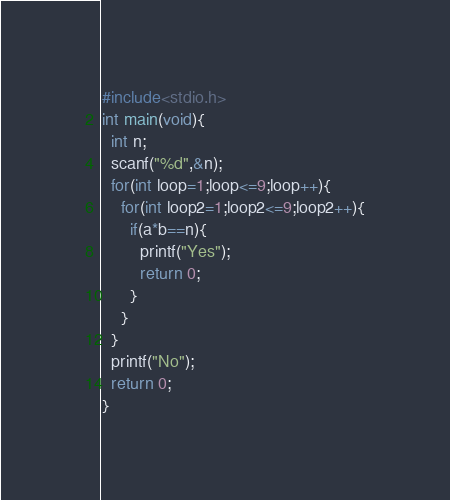<code> <loc_0><loc_0><loc_500><loc_500><_C++_>#include<stdio.h>
int main(void){
  int n;
  scanf("%d",&n);
  for(int loop=1;loop<=9;loop++){
    for(int loop2=1;loop2<=9;loop2++){
      if(a*b==n){
        printf("Yes");
        return 0;
      }
    }
  }
  printf("No");
  return 0;
}</code> 